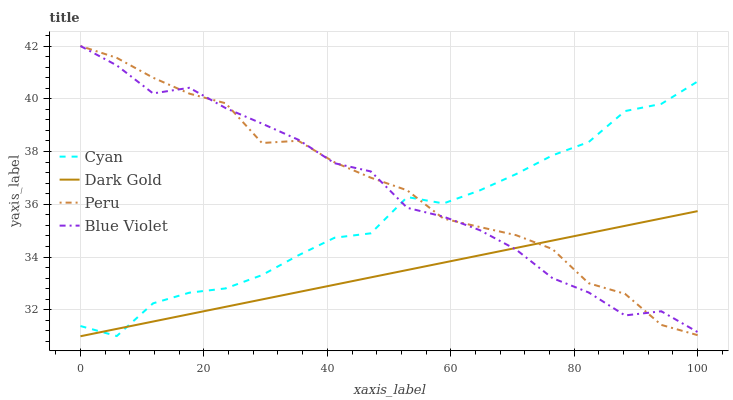Does Dark Gold have the minimum area under the curve?
Answer yes or no. Yes. Does Peru have the maximum area under the curve?
Answer yes or no. Yes. Does Blue Violet have the minimum area under the curve?
Answer yes or no. No. Does Blue Violet have the maximum area under the curve?
Answer yes or no. No. Is Dark Gold the smoothest?
Answer yes or no. Yes. Is Cyan the roughest?
Answer yes or no. Yes. Is Blue Violet the smoothest?
Answer yes or no. No. Is Blue Violet the roughest?
Answer yes or no. No. Does Dark Gold have the lowest value?
Answer yes or no. Yes. Does Peru have the lowest value?
Answer yes or no. No. Does Peru have the highest value?
Answer yes or no. Yes. Does Dark Gold have the highest value?
Answer yes or no. No. Does Dark Gold intersect Blue Violet?
Answer yes or no. Yes. Is Dark Gold less than Blue Violet?
Answer yes or no. No. Is Dark Gold greater than Blue Violet?
Answer yes or no. No. 